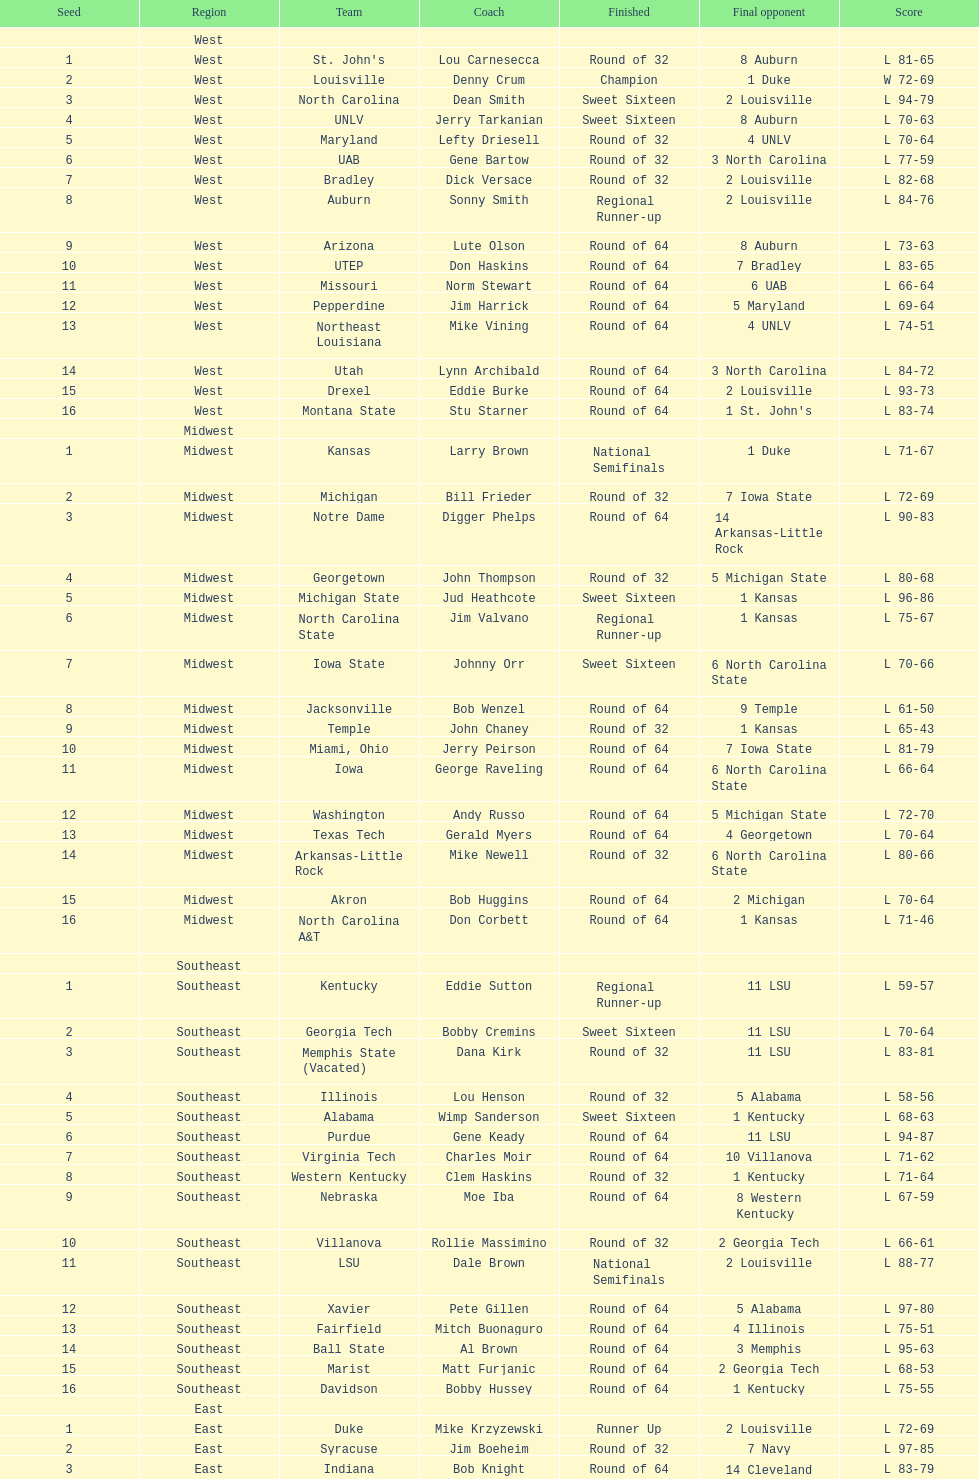How many teams are in the east region. 16. 